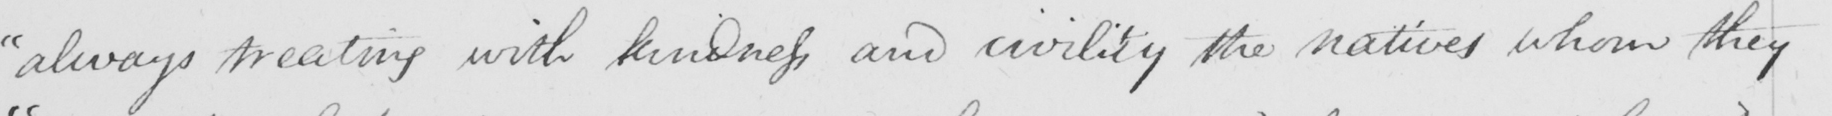Please transcribe the handwritten text in this image. " always treated with kindness and civility the natives whom they 